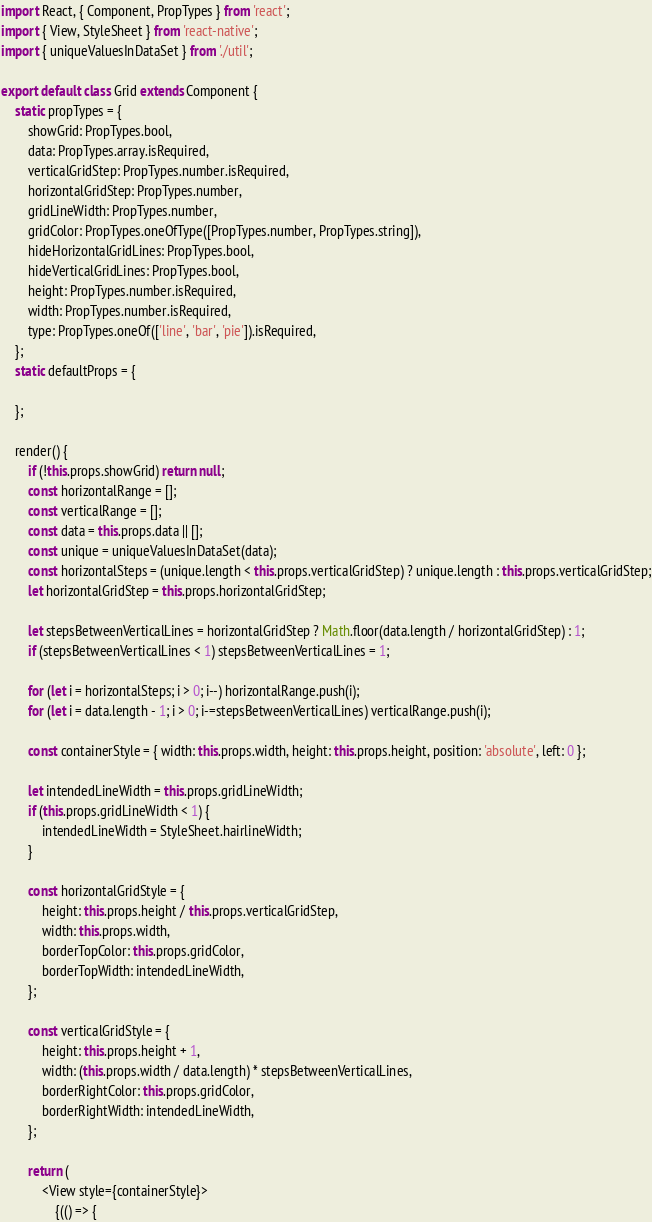<code> <loc_0><loc_0><loc_500><loc_500><_JavaScript_>import React, { Component, PropTypes } from 'react';
import { View, StyleSheet } from 'react-native';
import { uniqueValuesInDataSet } from './util';

export default class Grid extends Component {
	static propTypes = {
		showGrid: PropTypes.bool,
		data: PropTypes.array.isRequired,
		verticalGridStep: PropTypes.number.isRequired,
		horizontalGridStep: PropTypes.number,
		gridLineWidth: PropTypes.number,
		gridColor: PropTypes.oneOfType([PropTypes.number, PropTypes.string]),
		hideHorizontalGridLines: PropTypes.bool,
		hideVerticalGridLines: PropTypes.bool,
		height: PropTypes.number.isRequired,
		width: PropTypes.number.isRequired,
		type: PropTypes.oneOf(['line', 'bar', 'pie']).isRequired,
	};
	static defaultProps = {

	};

	render() {
		if (!this.props.showGrid) return null;
		const horizontalRange = [];
		const verticalRange = [];
		const data = this.props.data || [];
		const unique = uniqueValuesInDataSet(data);
		const horizontalSteps = (unique.length < this.props.verticalGridStep) ? unique.length : this.props.verticalGridStep;
		let horizontalGridStep = this.props.horizontalGridStep;

		let stepsBetweenVerticalLines = horizontalGridStep ? Math.floor(data.length / horizontalGridStep) : 1;
		if (stepsBetweenVerticalLines < 1) stepsBetweenVerticalLines = 1;

		for (let i = horizontalSteps; i > 0; i--) horizontalRange.push(i);
		for (let i = data.length - 1; i > 0; i-=stepsBetweenVerticalLines) verticalRange.push(i);

		const containerStyle = { width: this.props.width, height: this.props.height, position: 'absolute', left: 0 };

		let intendedLineWidth = this.props.gridLineWidth;
		if (this.props.gridLineWidth < 1) {
			intendedLineWidth = StyleSheet.hairlineWidth;
		}

		const horizontalGridStyle = {
			height: this.props.height / this.props.verticalGridStep,
			width: this.props.width,
			borderTopColor: this.props.gridColor,
			borderTopWidth: intendedLineWidth,
		};

		const verticalGridStyle = {
			height: this.props.height + 1,
			width: (this.props.width / data.length) * stepsBetweenVerticalLines,
			borderRightColor: this.props.gridColor,
			borderRightWidth: intendedLineWidth,
		};

		return (
			<View style={containerStyle}>
				{(() => {</code> 